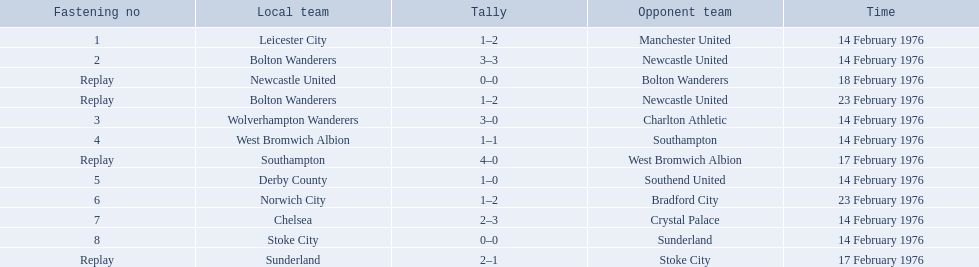What are all of the scores of the 1975-76 fa cup? 1–2, 3–3, 0–0, 1–2, 3–0, 1–1, 4–0, 1–0, 1–2, 2–3, 0–0, 2–1. What are the scores for manchester united or wolverhampton wanderers? 1–2, 3–0. Which has the highest score? 3–0. Who was this score for? Wolverhampton Wanderers. 